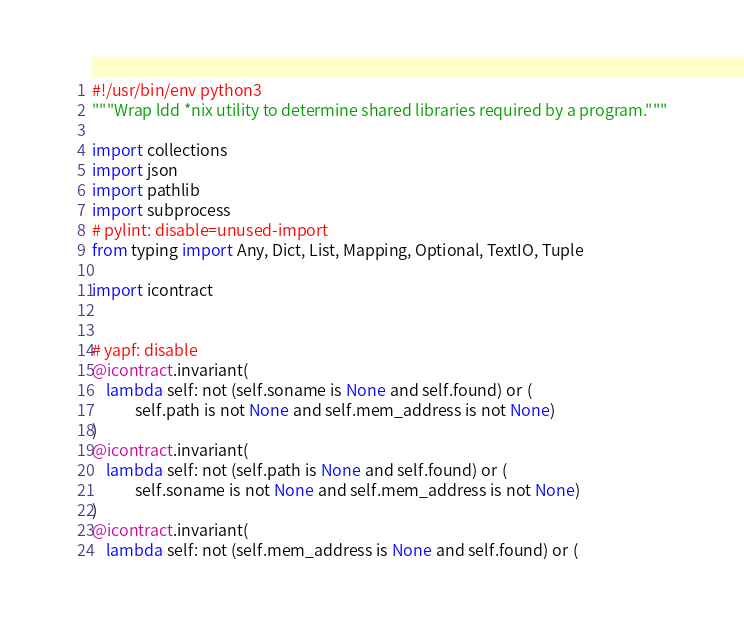Convert code to text. <code><loc_0><loc_0><loc_500><loc_500><_Python_>#!/usr/bin/env python3
"""Wrap ldd *nix utility to determine shared libraries required by a program."""

import collections
import json
import pathlib
import subprocess
# pylint: disable=unused-import
from typing import Any, Dict, List, Mapping, Optional, TextIO, Tuple

import icontract


# yapf: disable
@icontract.invariant(
    lambda self: not (self.soname is None and self.found) or (
            self.path is not None and self.mem_address is not None)
)
@icontract.invariant(
    lambda self: not (self.path is None and self.found) or (
            self.soname is not None and self.mem_address is not None)
)
@icontract.invariant(
    lambda self: not (self.mem_address is None and self.found) or (</code> 